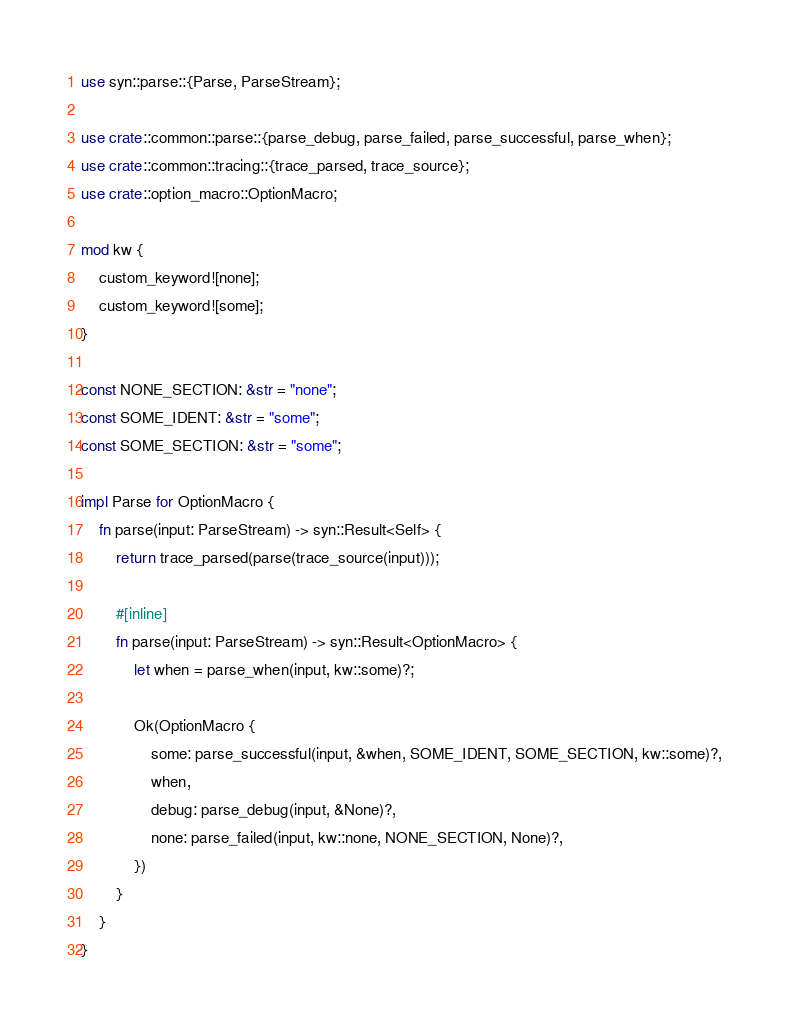<code> <loc_0><loc_0><loc_500><loc_500><_Rust_>use syn::parse::{Parse, ParseStream};

use crate::common::parse::{parse_debug, parse_failed, parse_successful, parse_when};
use crate::common::tracing::{trace_parsed, trace_source};
use crate::option_macro::OptionMacro;

mod kw {
    custom_keyword![none];
    custom_keyword![some];
}

const NONE_SECTION: &str = "none";
const SOME_IDENT: &str = "some";
const SOME_SECTION: &str = "some";

impl Parse for OptionMacro {
    fn parse(input: ParseStream) -> syn::Result<Self> {
        return trace_parsed(parse(trace_source(input)));

        #[inline]
        fn parse(input: ParseStream) -> syn::Result<OptionMacro> {
            let when = parse_when(input, kw::some)?;

            Ok(OptionMacro {
                some: parse_successful(input, &when, SOME_IDENT, SOME_SECTION, kw::some)?,
                when,
                debug: parse_debug(input, &None)?,
                none: parse_failed(input, kw::none, NONE_SECTION, None)?,
            })
        }
    }
}
</code> 